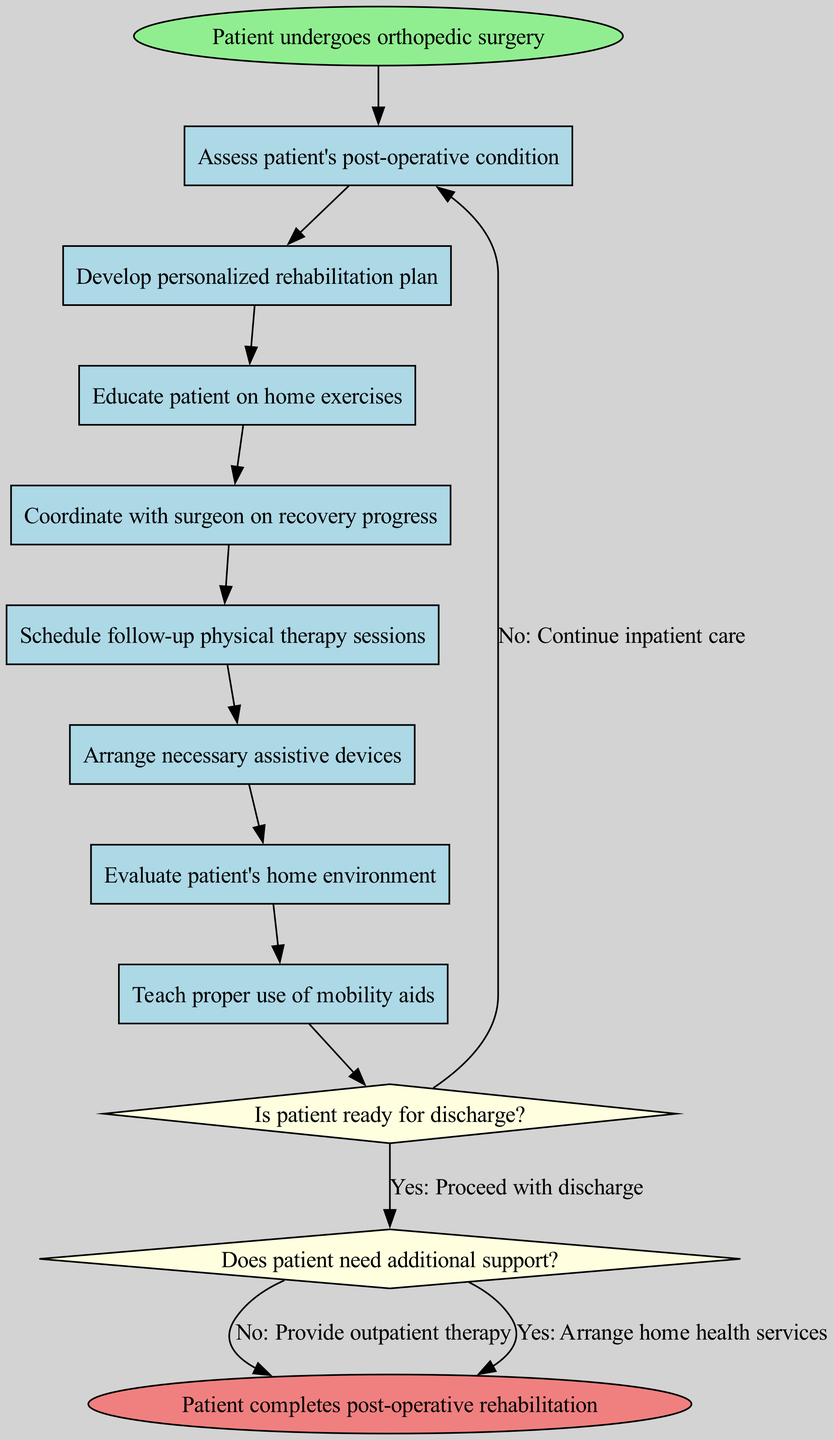What is the first activity after the patient undergoes surgery? The diagram starts with the node labeled "Patient undergoes orthopedic surgery." The first activity that directly follows this start node is "Assess patient's post-operative condition."
Answer: Assess patient's post-operative condition How many activities are in the diagram? The diagram lists eight activities, as counted from the activities section provided in the data.
Answer: 8 What decision follows the last activity? Following the last activity of the diagram, which is "Teach proper use of mobility aids," the next node is a decision labeled "Is patient ready for discharge?"
Answer: Is patient ready for discharge? What happens if the patient is not ready for discharge? If the answer to the decision "Is patient ready for discharge?" is "No," the flow continues to the activity labeled "Continue inpatient care." This indicates that additional care will be provided before discharge.
Answer: Continue inpatient care What are the two possible outcomes after the discharge decision? Upon reaching the decision "Is patient ready for discharge?" and if the answer is "Yes," there are two possible outcomes based on the next decision "Does patient need additional support?" which leads to either "Arrange home health services" or "Provide outpatient therapy."
Answer: Arrange home health services, Provide outpatient therapy How many edges connect the activities in the diagram? Each of the activities is connected sequentially, and since there are 8 activities, there are 7 edges connecting them, plus edges from the final activity to the first decision. This results in a total of 8 edges connecting all activities.
Answer: 8 What is the end node of the diagram? The final node of the diagram is labeled "Patient completes post-operative rehabilitation." This denotes the conclusion of the discharge planning and follow-up care coordination process.
Answer: Patient completes post-operative rehabilitation What action is taken if the patient needs additional support after discharge? If the decision is made that the patient needs additional support after the discharge decision, the workflow leads to arranging home health services, as detailed in the flow post-decision.
Answer: Arrange home health services 